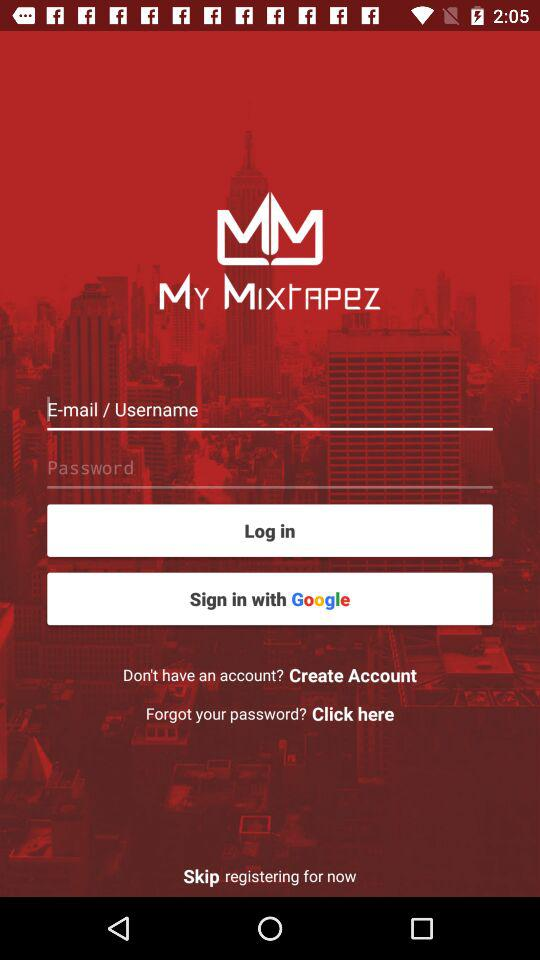What is the application name? The application name is "MY MIXTAPeZ". 